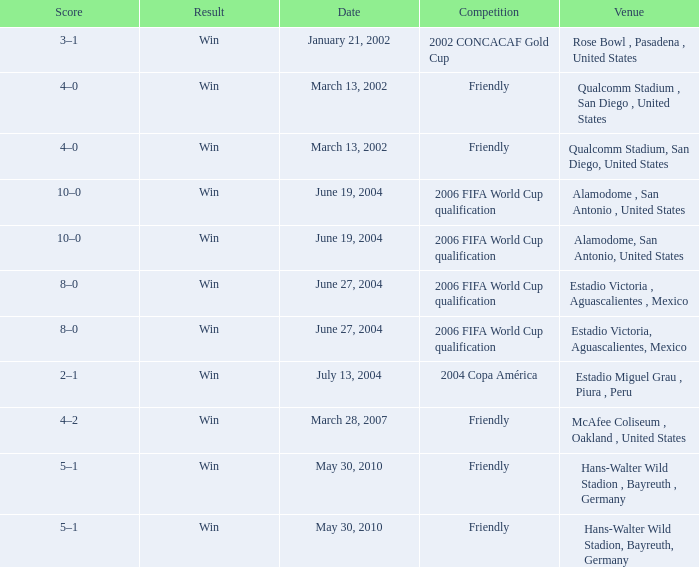What date has alamodome, san antonio, united states as the venue? June 19, 2004, June 19, 2004. 